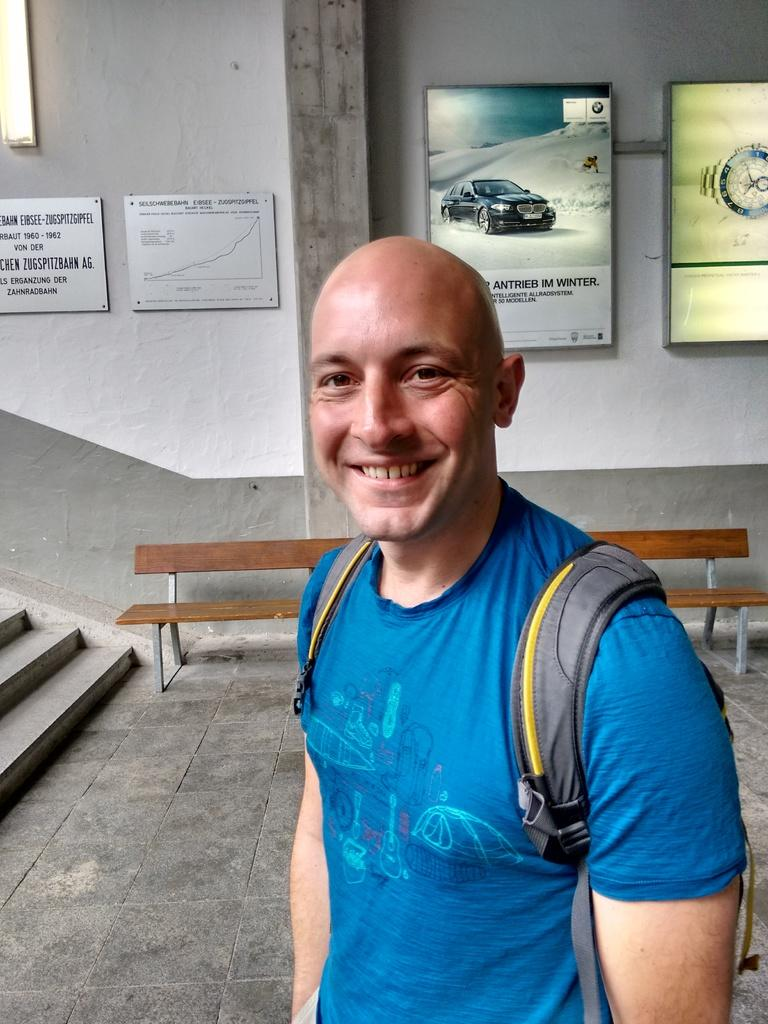What is the person in the image doing? The person is standing in the image. What is the person wearing? The person is wearing a bag. What is the person's facial expression? The person is smiling in the image. What type of fang can be seen in the person's mouth in the image? There is no fang visible in the person's mouth in the image. What color is the egg that the person is holding in the image? There is no egg present in the image. 